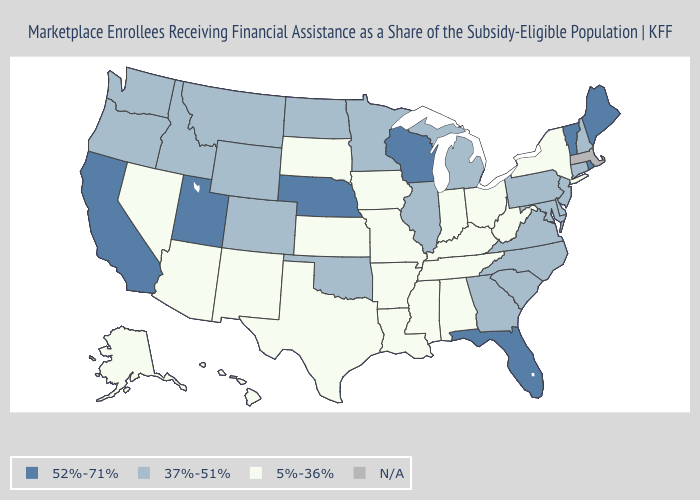Name the states that have a value in the range 37%-51%?
Quick response, please. Colorado, Connecticut, Delaware, Georgia, Idaho, Illinois, Maryland, Michigan, Minnesota, Montana, New Hampshire, New Jersey, North Carolina, North Dakota, Oklahoma, Oregon, Pennsylvania, South Carolina, Virginia, Washington, Wyoming. Name the states that have a value in the range 37%-51%?
Be succinct. Colorado, Connecticut, Delaware, Georgia, Idaho, Illinois, Maryland, Michigan, Minnesota, Montana, New Hampshire, New Jersey, North Carolina, North Dakota, Oklahoma, Oregon, Pennsylvania, South Carolina, Virginia, Washington, Wyoming. What is the value of Alaska?
Keep it brief. 5%-36%. Name the states that have a value in the range 37%-51%?
Keep it brief. Colorado, Connecticut, Delaware, Georgia, Idaho, Illinois, Maryland, Michigan, Minnesota, Montana, New Hampshire, New Jersey, North Carolina, North Dakota, Oklahoma, Oregon, Pennsylvania, South Carolina, Virginia, Washington, Wyoming. What is the lowest value in the USA?
Short answer required. 5%-36%. What is the value of Montana?
Be succinct. 37%-51%. Does Wyoming have the lowest value in the West?
Concise answer only. No. What is the value of New Jersey?
Be succinct. 37%-51%. Which states have the highest value in the USA?
Be succinct. California, Florida, Maine, Nebraska, Rhode Island, Utah, Vermont, Wisconsin. What is the highest value in the USA?
Quick response, please. 52%-71%. What is the value of North Carolina?
Write a very short answer. 37%-51%. Name the states that have a value in the range 37%-51%?
Concise answer only. Colorado, Connecticut, Delaware, Georgia, Idaho, Illinois, Maryland, Michigan, Minnesota, Montana, New Hampshire, New Jersey, North Carolina, North Dakota, Oklahoma, Oregon, Pennsylvania, South Carolina, Virginia, Washington, Wyoming. Name the states that have a value in the range N/A?
Be succinct. Massachusetts. 